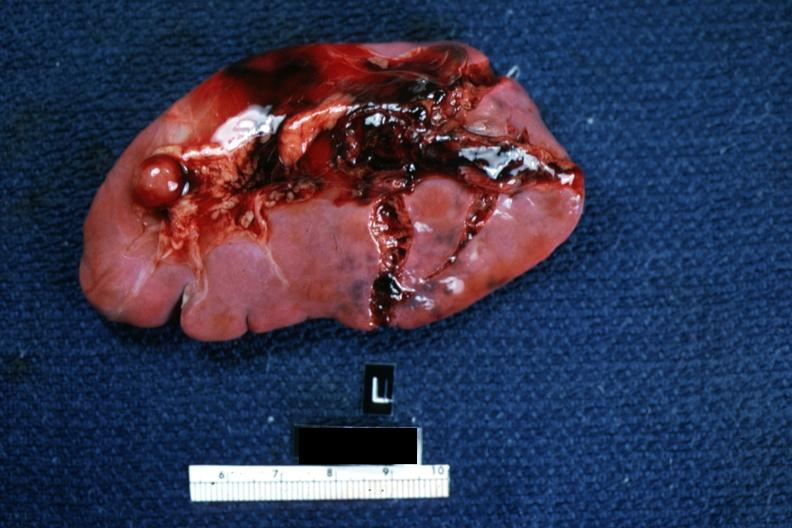s spleen present?
Answer the question using a single word or phrase. Yes 